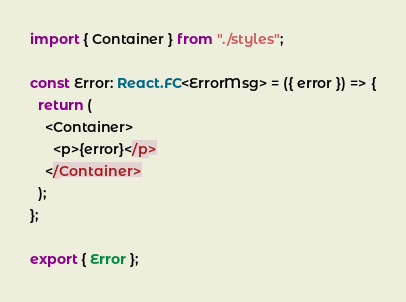Convert code to text. <code><loc_0><loc_0><loc_500><loc_500><_TypeScript_>import { Container } from "./styles";

const Error: React.FC<ErrorMsg> = ({ error }) => {
  return (
    <Container>
      <p>{error}</p>
    </Container>
  );
};

export { Error };
</code> 